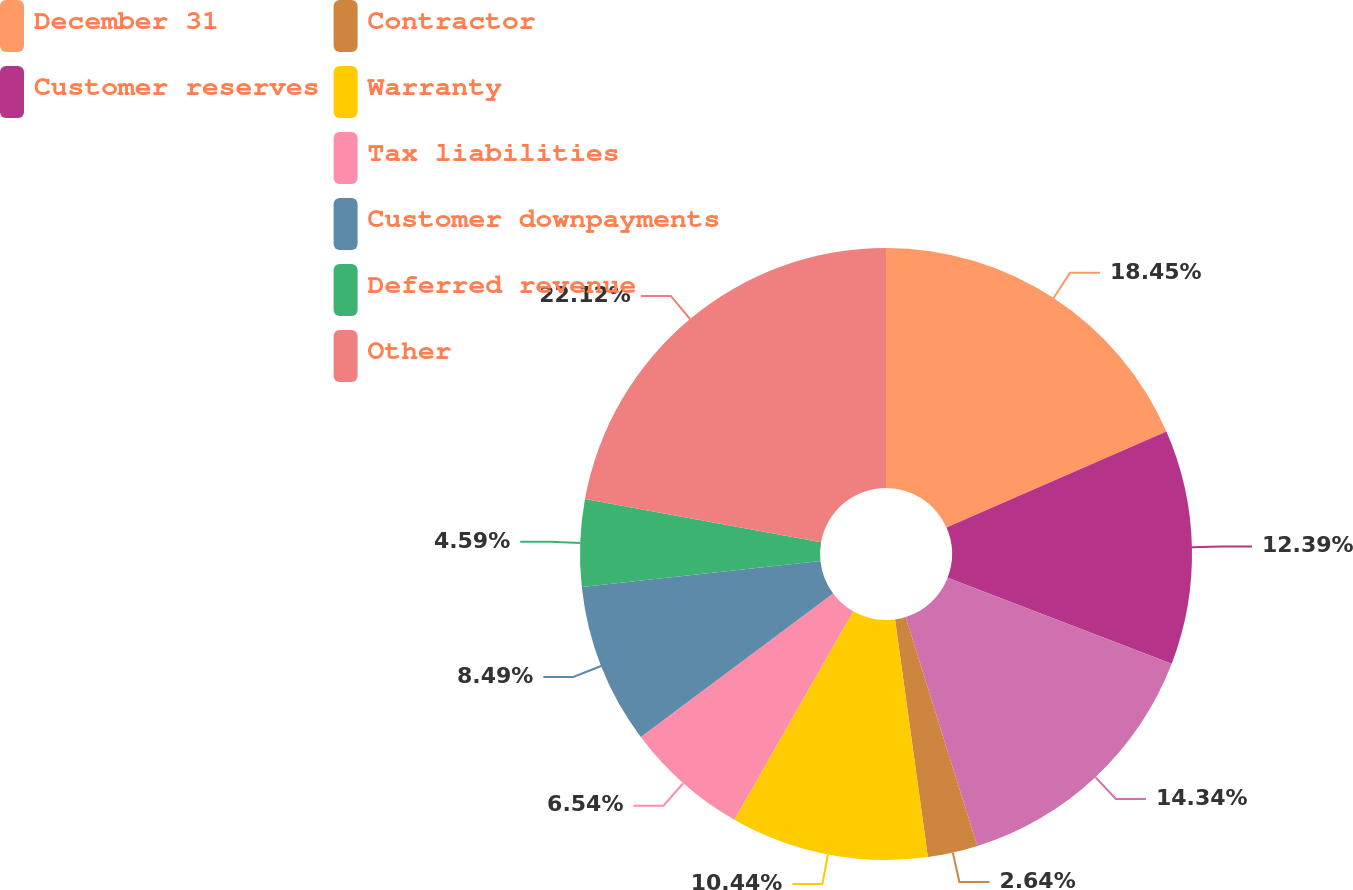Convert chart. <chart><loc_0><loc_0><loc_500><loc_500><pie_chart><fcel>December 31<fcel>Customer reserves<fcel>Unnamed: 2<fcel>Contractor<fcel>Warranty<fcel>Tax liabilities<fcel>Customer downpayments<fcel>Deferred revenue<fcel>Other<nl><fcel>18.45%<fcel>12.39%<fcel>14.34%<fcel>2.64%<fcel>10.44%<fcel>6.54%<fcel>8.49%<fcel>4.59%<fcel>22.13%<nl></chart> 